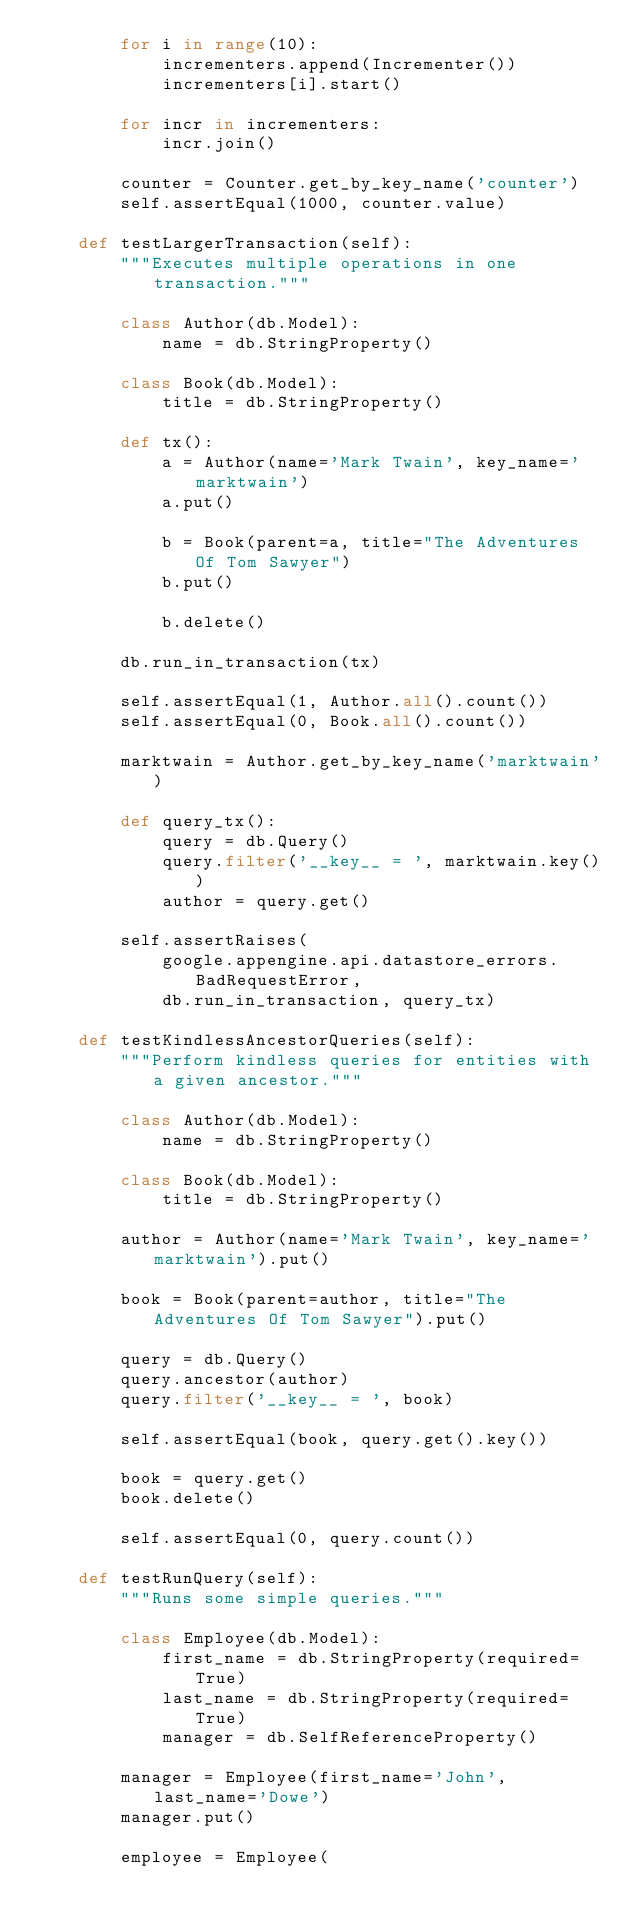<code> <loc_0><loc_0><loc_500><loc_500><_Python_>        for i in range(10):
            incrementers.append(Incrementer())
            incrementers[i].start()

        for incr in incrementers:
            incr.join()

        counter = Counter.get_by_key_name('counter')
        self.assertEqual(1000, counter.value)

    def testLargerTransaction(self):
        """Executes multiple operations in one transaction."""

        class Author(db.Model):
            name = db.StringProperty()

        class Book(db.Model):
            title = db.StringProperty()

        def tx():
            a = Author(name='Mark Twain', key_name='marktwain')
            a.put()

            b = Book(parent=a, title="The Adventures Of Tom Sawyer")
            b.put()

            b.delete()

        db.run_in_transaction(tx)

        self.assertEqual(1, Author.all().count())
        self.assertEqual(0, Book.all().count())

        marktwain = Author.get_by_key_name('marktwain')

        def query_tx():
            query = db.Query()
            query.filter('__key__ = ', marktwain.key())
            author = query.get()

        self.assertRaises(
            google.appengine.api.datastore_errors.BadRequestError,
            db.run_in_transaction, query_tx)

    def testKindlessAncestorQueries(self):
        """Perform kindless queries for entities with a given ancestor."""

        class Author(db.Model):
            name = db.StringProperty()

        class Book(db.Model):
            title = db.StringProperty()

        author = Author(name='Mark Twain', key_name='marktwain').put()

        book = Book(parent=author, title="The Adventures Of Tom Sawyer").put()

        query = db.Query()
        query.ancestor(author)
        query.filter('__key__ = ', book)

        self.assertEqual(book, query.get().key())

        book = query.get()
        book.delete()

        self.assertEqual(0, query.count())

    def testRunQuery(self):
        """Runs some simple queries."""

        class Employee(db.Model):
            first_name = db.StringProperty(required=True)
            last_name = db.StringProperty(required=True)
            manager = db.SelfReferenceProperty()

        manager = Employee(first_name='John', last_name='Dowe')
        manager.put()

        employee = Employee(</code> 